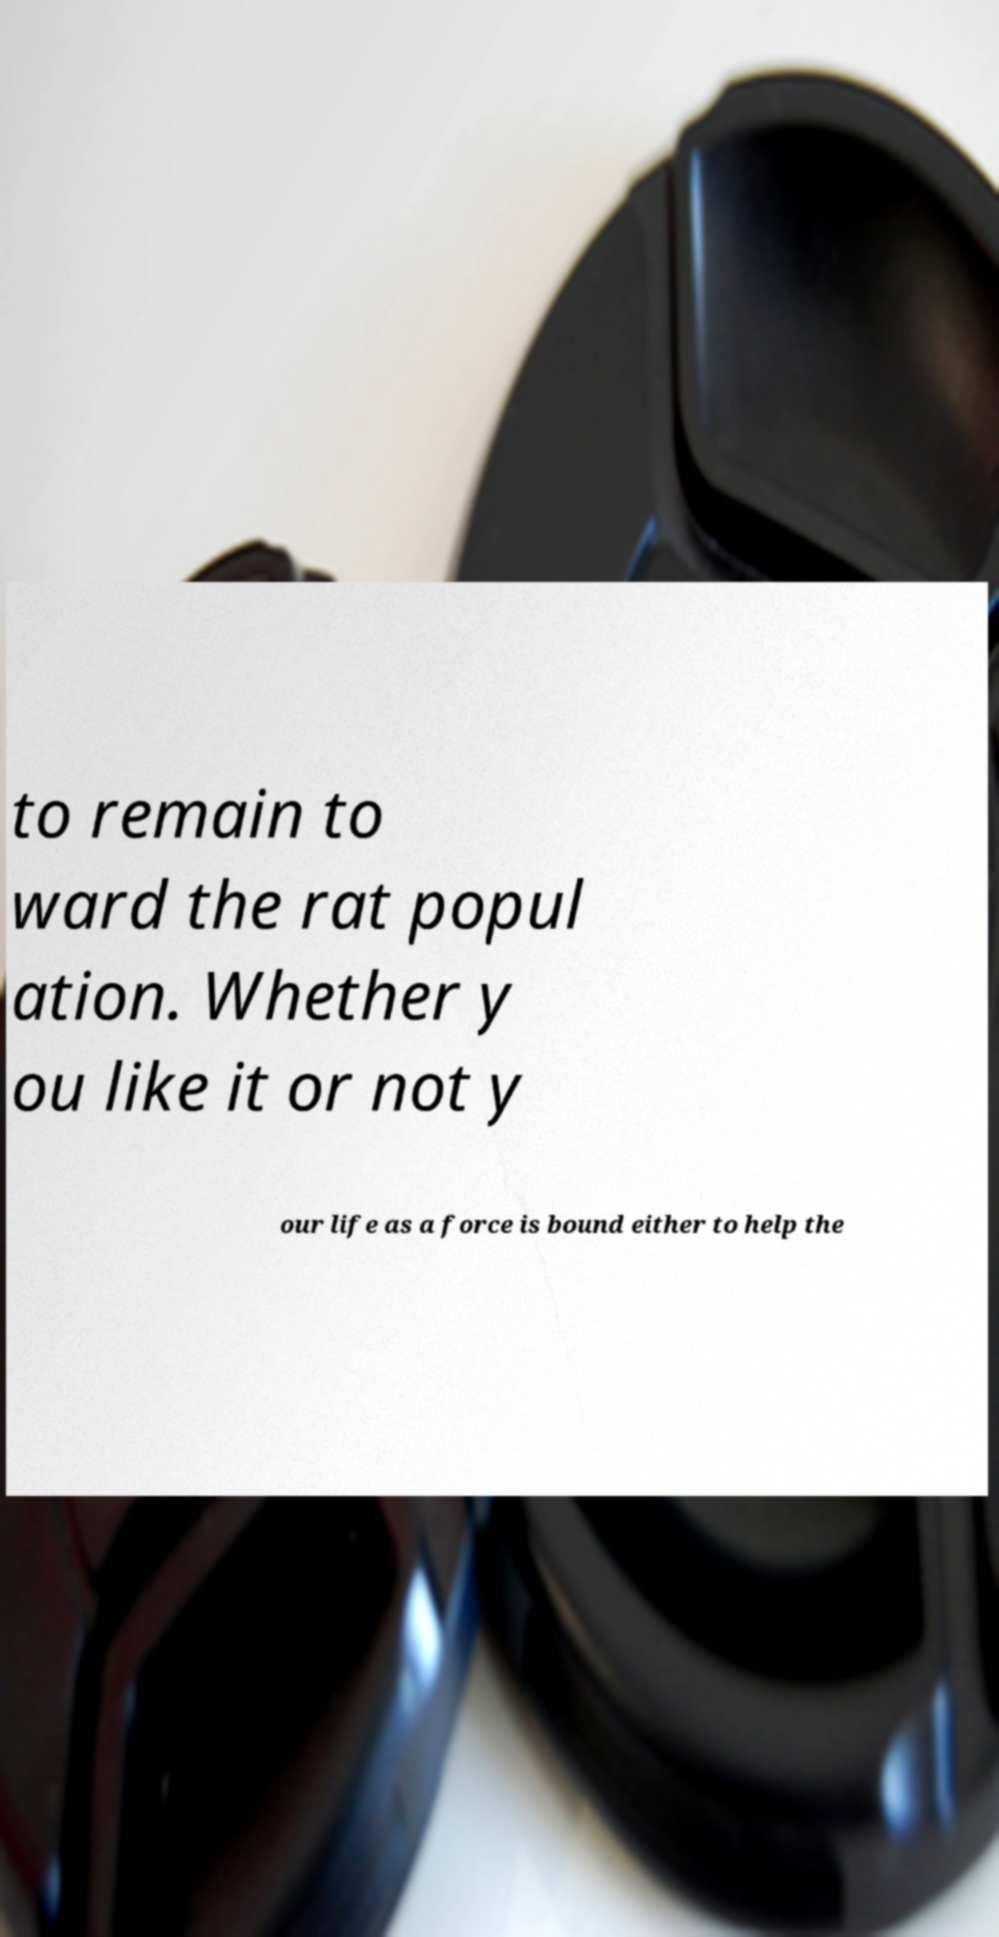Can you accurately transcribe the text from the provided image for me? to remain to ward the rat popul ation. Whether y ou like it or not y our life as a force is bound either to help the 